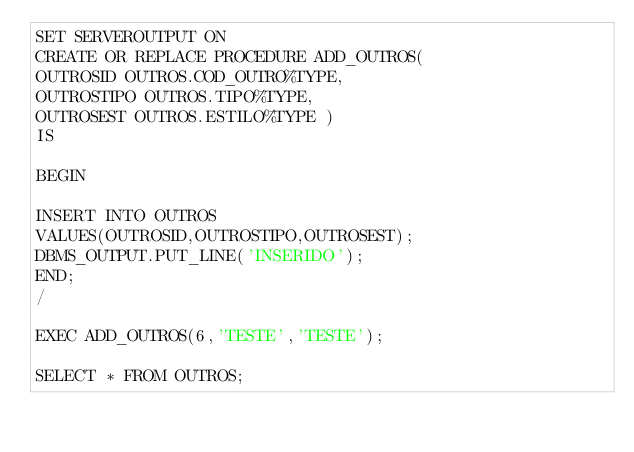<code> <loc_0><loc_0><loc_500><loc_500><_SQL_>SET SERVEROUTPUT ON
CREATE OR REPLACE PROCEDURE ADD_OUTROS(
OUTROSID OUTROS.COD_OUTRO%TYPE,
OUTROSTIPO OUTROS.TIPO%TYPE,
OUTROSEST OUTROS.ESTILO%TYPE ) 
IS

BEGIN

INSERT INTO OUTROS
VALUES(OUTROSID,OUTROSTIPO,OUTROSEST);
DBMS_OUTPUT.PUT_LINE('INSERIDO');
END;
/

EXEC ADD_OUTROS(6,'TESTE','TESTE');

SELECT * FROM OUTROS;</code> 